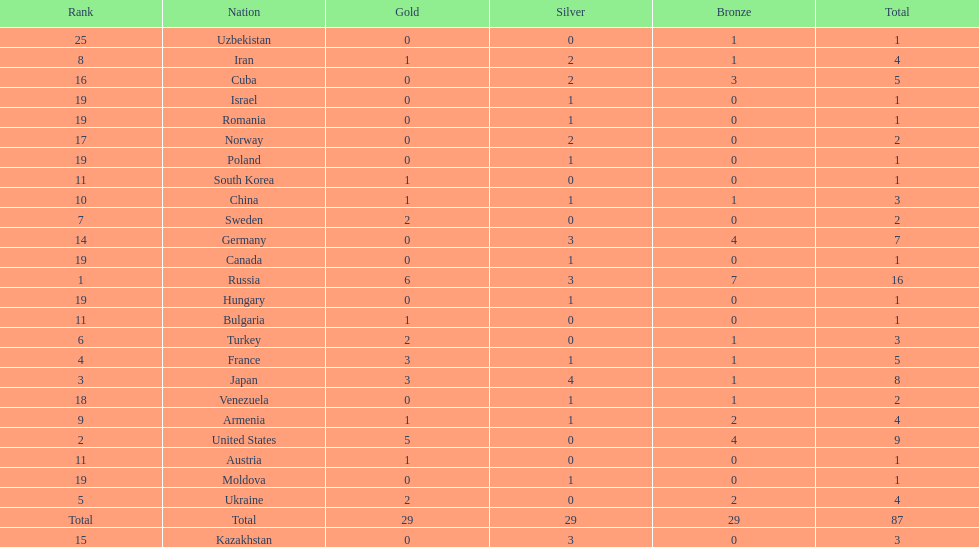How many combined gold medals did japan and france win? 6. 